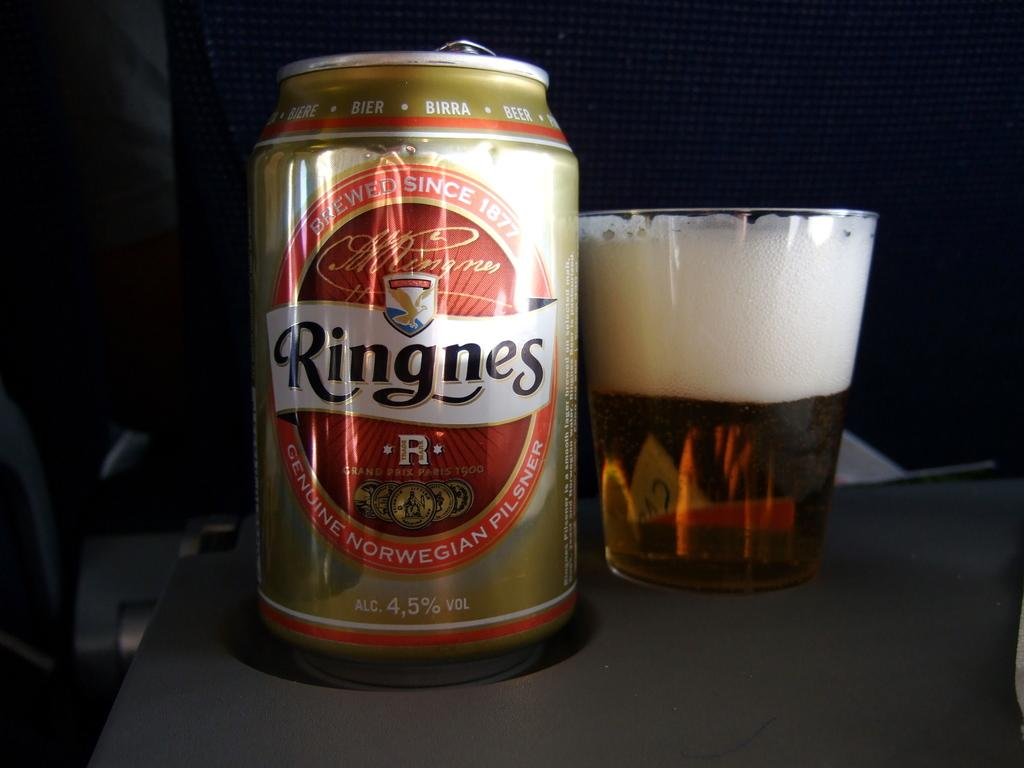<image>
Share a concise interpretation of the image provided. A can of Ringes Genuine Norwegian Pilsner beer is next to a half full glass. 